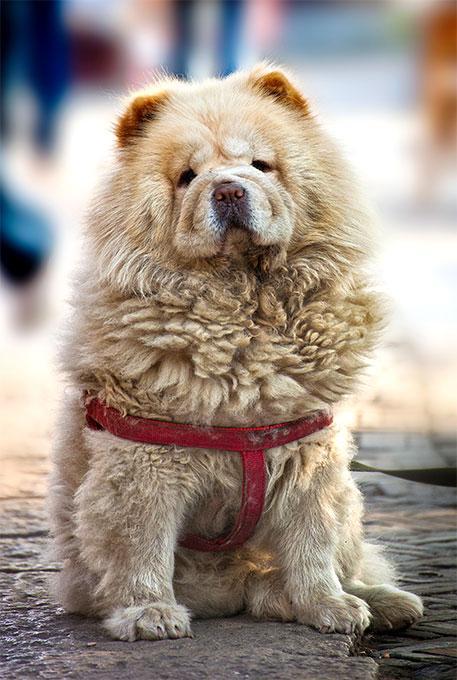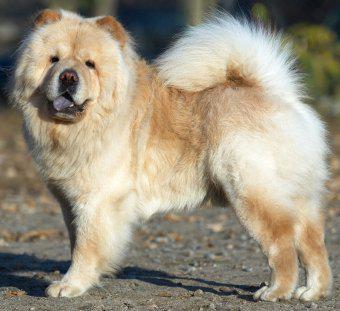The first image is the image on the left, the second image is the image on the right. Given the left and right images, does the statement "The dog in the image on the right is in the grass." hold true? Answer yes or no. No. The first image is the image on the left, the second image is the image on the right. Examine the images to the left and right. Is the description "A chow dog is standing on all fours on a grayish hard surface, with its body turned leftward." accurate? Answer yes or no. Yes. 